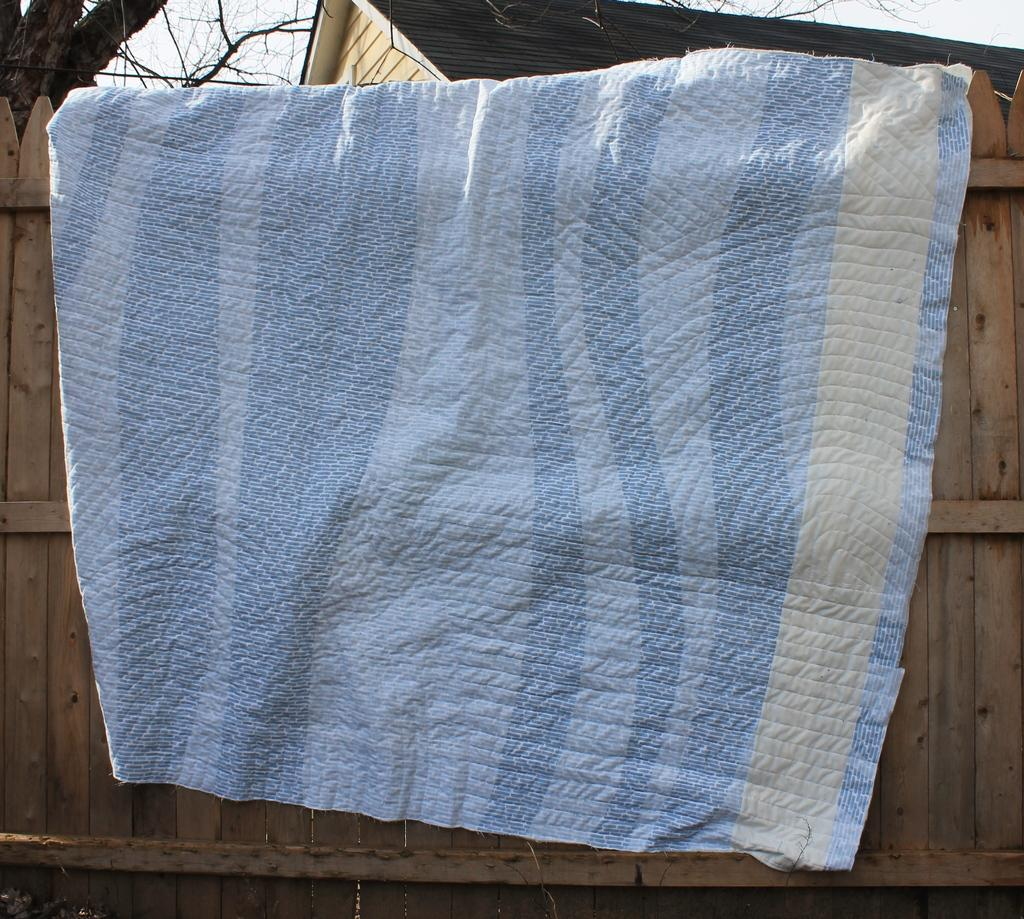What color is the cloth in the image? The cloth in the image is blue. Where is the cloth located? The cloth is placed on a wooden fence wall. How many legs does the pot have in the image? There is no pot present in the image, so it is not possible to determine how many legs it might have. 